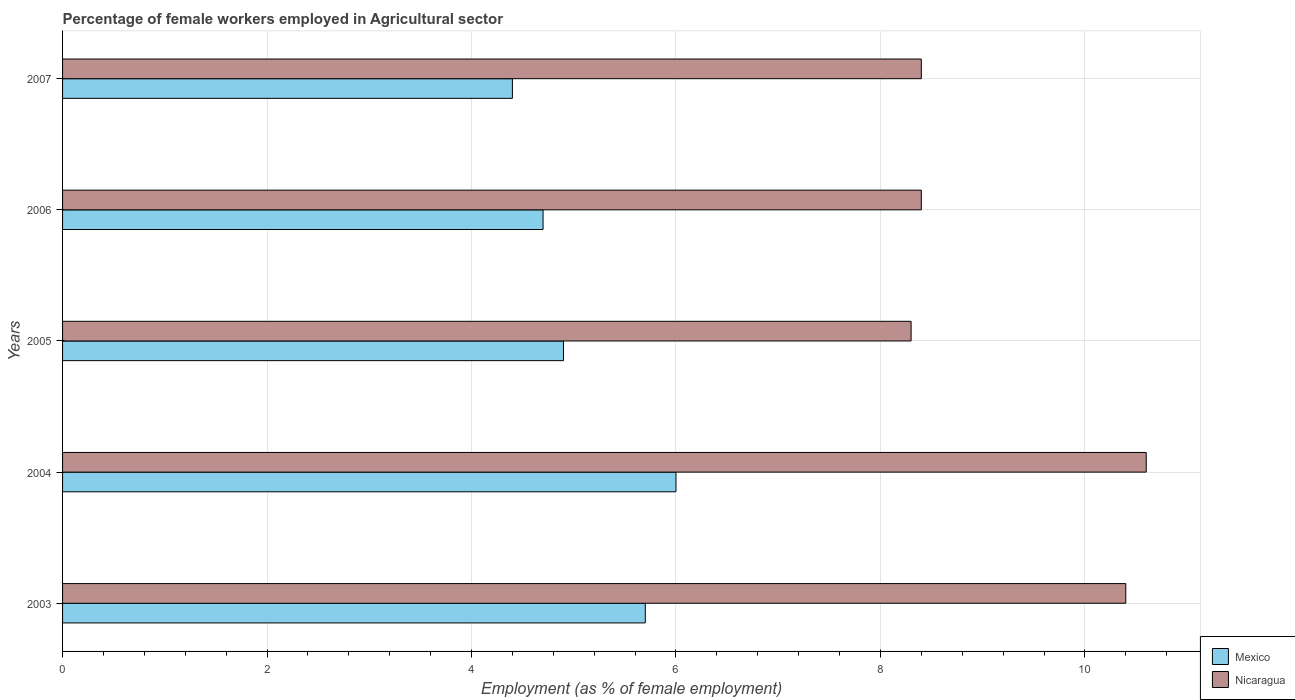How many groups of bars are there?
Your response must be concise. 5. Are the number of bars per tick equal to the number of legend labels?
Offer a terse response. Yes. How many bars are there on the 1st tick from the top?
Make the answer very short. 2. What is the label of the 2nd group of bars from the top?
Make the answer very short. 2006. In how many cases, is the number of bars for a given year not equal to the number of legend labels?
Provide a succinct answer. 0. What is the percentage of females employed in Agricultural sector in Nicaragua in 2006?
Give a very brief answer. 8.4. Across all years, what is the maximum percentage of females employed in Agricultural sector in Nicaragua?
Provide a succinct answer. 10.6. Across all years, what is the minimum percentage of females employed in Agricultural sector in Nicaragua?
Your response must be concise. 8.3. In which year was the percentage of females employed in Agricultural sector in Nicaragua minimum?
Your response must be concise. 2005. What is the total percentage of females employed in Agricultural sector in Mexico in the graph?
Provide a short and direct response. 25.7. What is the difference between the percentage of females employed in Agricultural sector in Mexico in 2003 and that in 2005?
Your answer should be very brief. 0.8. What is the difference between the percentage of females employed in Agricultural sector in Mexico in 2006 and the percentage of females employed in Agricultural sector in Nicaragua in 2003?
Ensure brevity in your answer.  -5.7. What is the average percentage of females employed in Agricultural sector in Nicaragua per year?
Give a very brief answer. 9.22. In the year 2003, what is the difference between the percentage of females employed in Agricultural sector in Nicaragua and percentage of females employed in Agricultural sector in Mexico?
Offer a very short reply. 4.7. What is the ratio of the percentage of females employed in Agricultural sector in Nicaragua in 2003 to that in 2007?
Your answer should be very brief. 1.24. Is the percentage of females employed in Agricultural sector in Nicaragua in 2003 less than that in 2004?
Offer a terse response. Yes. What is the difference between the highest and the second highest percentage of females employed in Agricultural sector in Mexico?
Offer a very short reply. 0.3. What is the difference between the highest and the lowest percentage of females employed in Agricultural sector in Nicaragua?
Keep it short and to the point. 2.3. In how many years, is the percentage of females employed in Agricultural sector in Nicaragua greater than the average percentage of females employed in Agricultural sector in Nicaragua taken over all years?
Ensure brevity in your answer.  2. Is the sum of the percentage of females employed in Agricultural sector in Nicaragua in 2006 and 2007 greater than the maximum percentage of females employed in Agricultural sector in Mexico across all years?
Provide a short and direct response. Yes. What does the 1st bar from the top in 2003 represents?
Offer a very short reply. Nicaragua. What does the 1st bar from the bottom in 2003 represents?
Your response must be concise. Mexico. Are all the bars in the graph horizontal?
Make the answer very short. Yes. How many years are there in the graph?
Your answer should be very brief. 5. What is the difference between two consecutive major ticks on the X-axis?
Your answer should be compact. 2. Are the values on the major ticks of X-axis written in scientific E-notation?
Keep it short and to the point. No. How many legend labels are there?
Make the answer very short. 2. What is the title of the graph?
Offer a very short reply. Percentage of female workers employed in Agricultural sector. Does "Other small states" appear as one of the legend labels in the graph?
Ensure brevity in your answer.  No. What is the label or title of the X-axis?
Provide a succinct answer. Employment (as % of female employment). What is the label or title of the Y-axis?
Your answer should be compact. Years. What is the Employment (as % of female employment) in Mexico in 2003?
Make the answer very short. 5.7. What is the Employment (as % of female employment) of Nicaragua in 2003?
Your answer should be very brief. 10.4. What is the Employment (as % of female employment) of Mexico in 2004?
Make the answer very short. 6. What is the Employment (as % of female employment) in Nicaragua in 2004?
Your answer should be very brief. 10.6. What is the Employment (as % of female employment) in Mexico in 2005?
Your answer should be very brief. 4.9. What is the Employment (as % of female employment) of Nicaragua in 2005?
Offer a terse response. 8.3. What is the Employment (as % of female employment) in Mexico in 2006?
Make the answer very short. 4.7. What is the Employment (as % of female employment) in Nicaragua in 2006?
Give a very brief answer. 8.4. What is the Employment (as % of female employment) in Mexico in 2007?
Ensure brevity in your answer.  4.4. What is the Employment (as % of female employment) of Nicaragua in 2007?
Ensure brevity in your answer.  8.4. Across all years, what is the maximum Employment (as % of female employment) in Mexico?
Provide a short and direct response. 6. Across all years, what is the maximum Employment (as % of female employment) of Nicaragua?
Keep it short and to the point. 10.6. Across all years, what is the minimum Employment (as % of female employment) of Mexico?
Keep it short and to the point. 4.4. Across all years, what is the minimum Employment (as % of female employment) in Nicaragua?
Provide a short and direct response. 8.3. What is the total Employment (as % of female employment) in Mexico in the graph?
Provide a succinct answer. 25.7. What is the total Employment (as % of female employment) in Nicaragua in the graph?
Offer a terse response. 46.1. What is the difference between the Employment (as % of female employment) in Nicaragua in 2003 and that in 2006?
Your answer should be compact. 2. What is the difference between the Employment (as % of female employment) in Mexico in 2004 and that in 2005?
Your answer should be compact. 1.1. What is the difference between the Employment (as % of female employment) in Nicaragua in 2004 and that in 2005?
Give a very brief answer. 2.3. What is the difference between the Employment (as % of female employment) in Mexico in 2004 and that in 2006?
Your response must be concise. 1.3. What is the difference between the Employment (as % of female employment) of Nicaragua in 2004 and that in 2006?
Ensure brevity in your answer.  2.2. What is the difference between the Employment (as % of female employment) of Mexico in 2004 and that in 2007?
Offer a very short reply. 1.6. What is the difference between the Employment (as % of female employment) in Nicaragua in 2005 and that in 2006?
Offer a terse response. -0.1. What is the difference between the Employment (as % of female employment) in Mexico in 2005 and that in 2007?
Your response must be concise. 0.5. What is the difference between the Employment (as % of female employment) in Nicaragua in 2005 and that in 2007?
Keep it short and to the point. -0.1. What is the difference between the Employment (as % of female employment) of Mexico in 2003 and the Employment (as % of female employment) of Nicaragua in 2004?
Ensure brevity in your answer.  -4.9. What is the difference between the Employment (as % of female employment) of Mexico in 2003 and the Employment (as % of female employment) of Nicaragua in 2005?
Your answer should be very brief. -2.6. What is the difference between the Employment (as % of female employment) of Mexico in 2003 and the Employment (as % of female employment) of Nicaragua in 2006?
Keep it short and to the point. -2.7. What is the difference between the Employment (as % of female employment) in Mexico in 2003 and the Employment (as % of female employment) in Nicaragua in 2007?
Offer a very short reply. -2.7. What is the difference between the Employment (as % of female employment) of Mexico in 2004 and the Employment (as % of female employment) of Nicaragua in 2005?
Provide a short and direct response. -2.3. What is the difference between the Employment (as % of female employment) in Mexico in 2004 and the Employment (as % of female employment) in Nicaragua in 2006?
Offer a very short reply. -2.4. What is the difference between the Employment (as % of female employment) of Mexico in 2004 and the Employment (as % of female employment) of Nicaragua in 2007?
Your response must be concise. -2.4. What is the difference between the Employment (as % of female employment) of Mexico in 2005 and the Employment (as % of female employment) of Nicaragua in 2006?
Make the answer very short. -3.5. What is the difference between the Employment (as % of female employment) of Mexico in 2005 and the Employment (as % of female employment) of Nicaragua in 2007?
Make the answer very short. -3.5. What is the average Employment (as % of female employment) in Mexico per year?
Your response must be concise. 5.14. What is the average Employment (as % of female employment) in Nicaragua per year?
Ensure brevity in your answer.  9.22. In the year 2003, what is the difference between the Employment (as % of female employment) of Mexico and Employment (as % of female employment) of Nicaragua?
Your response must be concise. -4.7. In the year 2006, what is the difference between the Employment (as % of female employment) in Mexico and Employment (as % of female employment) in Nicaragua?
Offer a terse response. -3.7. In the year 2007, what is the difference between the Employment (as % of female employment) of Mexico and Employment (as % of female employment) of Nicaragua?
Ensure brevity in your answer.  -4. What is the ratio of the Employment (as % of female employment) in Nicaragua in 2003 to that in 2004?
Ensure brevity in your answer.  0.98. What is the ratio of the Employment (as % of female employment) of Mexico in 2003 to that in 2005?
Provide a short and direct response. 1.16. What is the ratio of the Employment (as % of female employment) of Nicaragua in 2003 to that in 2005?
Your answer should be compact. 1.25. What is the ratio of the Employment (as % of female employment) in Mexico in 2003 to that in 2006?
Your response must be concise. 1.21. What is the ratio of the Employment (as % of female employment) in Nicaragua in 2003 to that in 2006?
Your answer should be very brief. 1.24. What is the ratio of the Employment (as % of female employment) of Mexico in 2003 to that in 2007?
Make the answer very short. 1.3. What is the ratio of the Employment (as % of female employment) in Nicaragua in 2003 to that in 2007?
Offer a very short reply. 1.24. What is the ratio of the Employment (as % of female employment) in Mexico in 2004 to that in 2005?
Give a very brief answer. 1.22. What is the ratio of the Employment (as % of female employment) in Nicaragua in 2004 to that in 2005?
Give a very brief answer. 1.28. What is the ratio of the Employment (as % of female employment) of Mexico in 2004 to that in 2006?
Your answer should be compact. 1.28. What is the ratio of the Employment (as % of female employment) in Nicaragua in 2004 to that in 2006?
Provide a short and direct response. 1.26. What is the ratio of the Employment (as % of female employment) of Mexico in 2004 to that in 2007?
Ensure brevity in your answer.  1.36. What is the ratio of the Employment (as % of female employment) in Nicaragua in 2004 to that in 2007?
Your response must be concise. 1.26. What is the ratio of the Employment (as % of female employment) in Mexico in 2005 to that in 2006?
Give a very brief answer. 1.04. What is the ratio of the Employment (as % of female employment) in Mexico in 2005 to that in 2007?
Your answer should be very brief. 1.11. What is the ratio of the Employment (as % of female employment) of Mexico in 2006 to that in 2007?
Your response must be concise. 1.07. What is the difference between the highest and the lowest Employment (as % of female employment) of Nicaragua?
Your response must be concise. 2.3. 